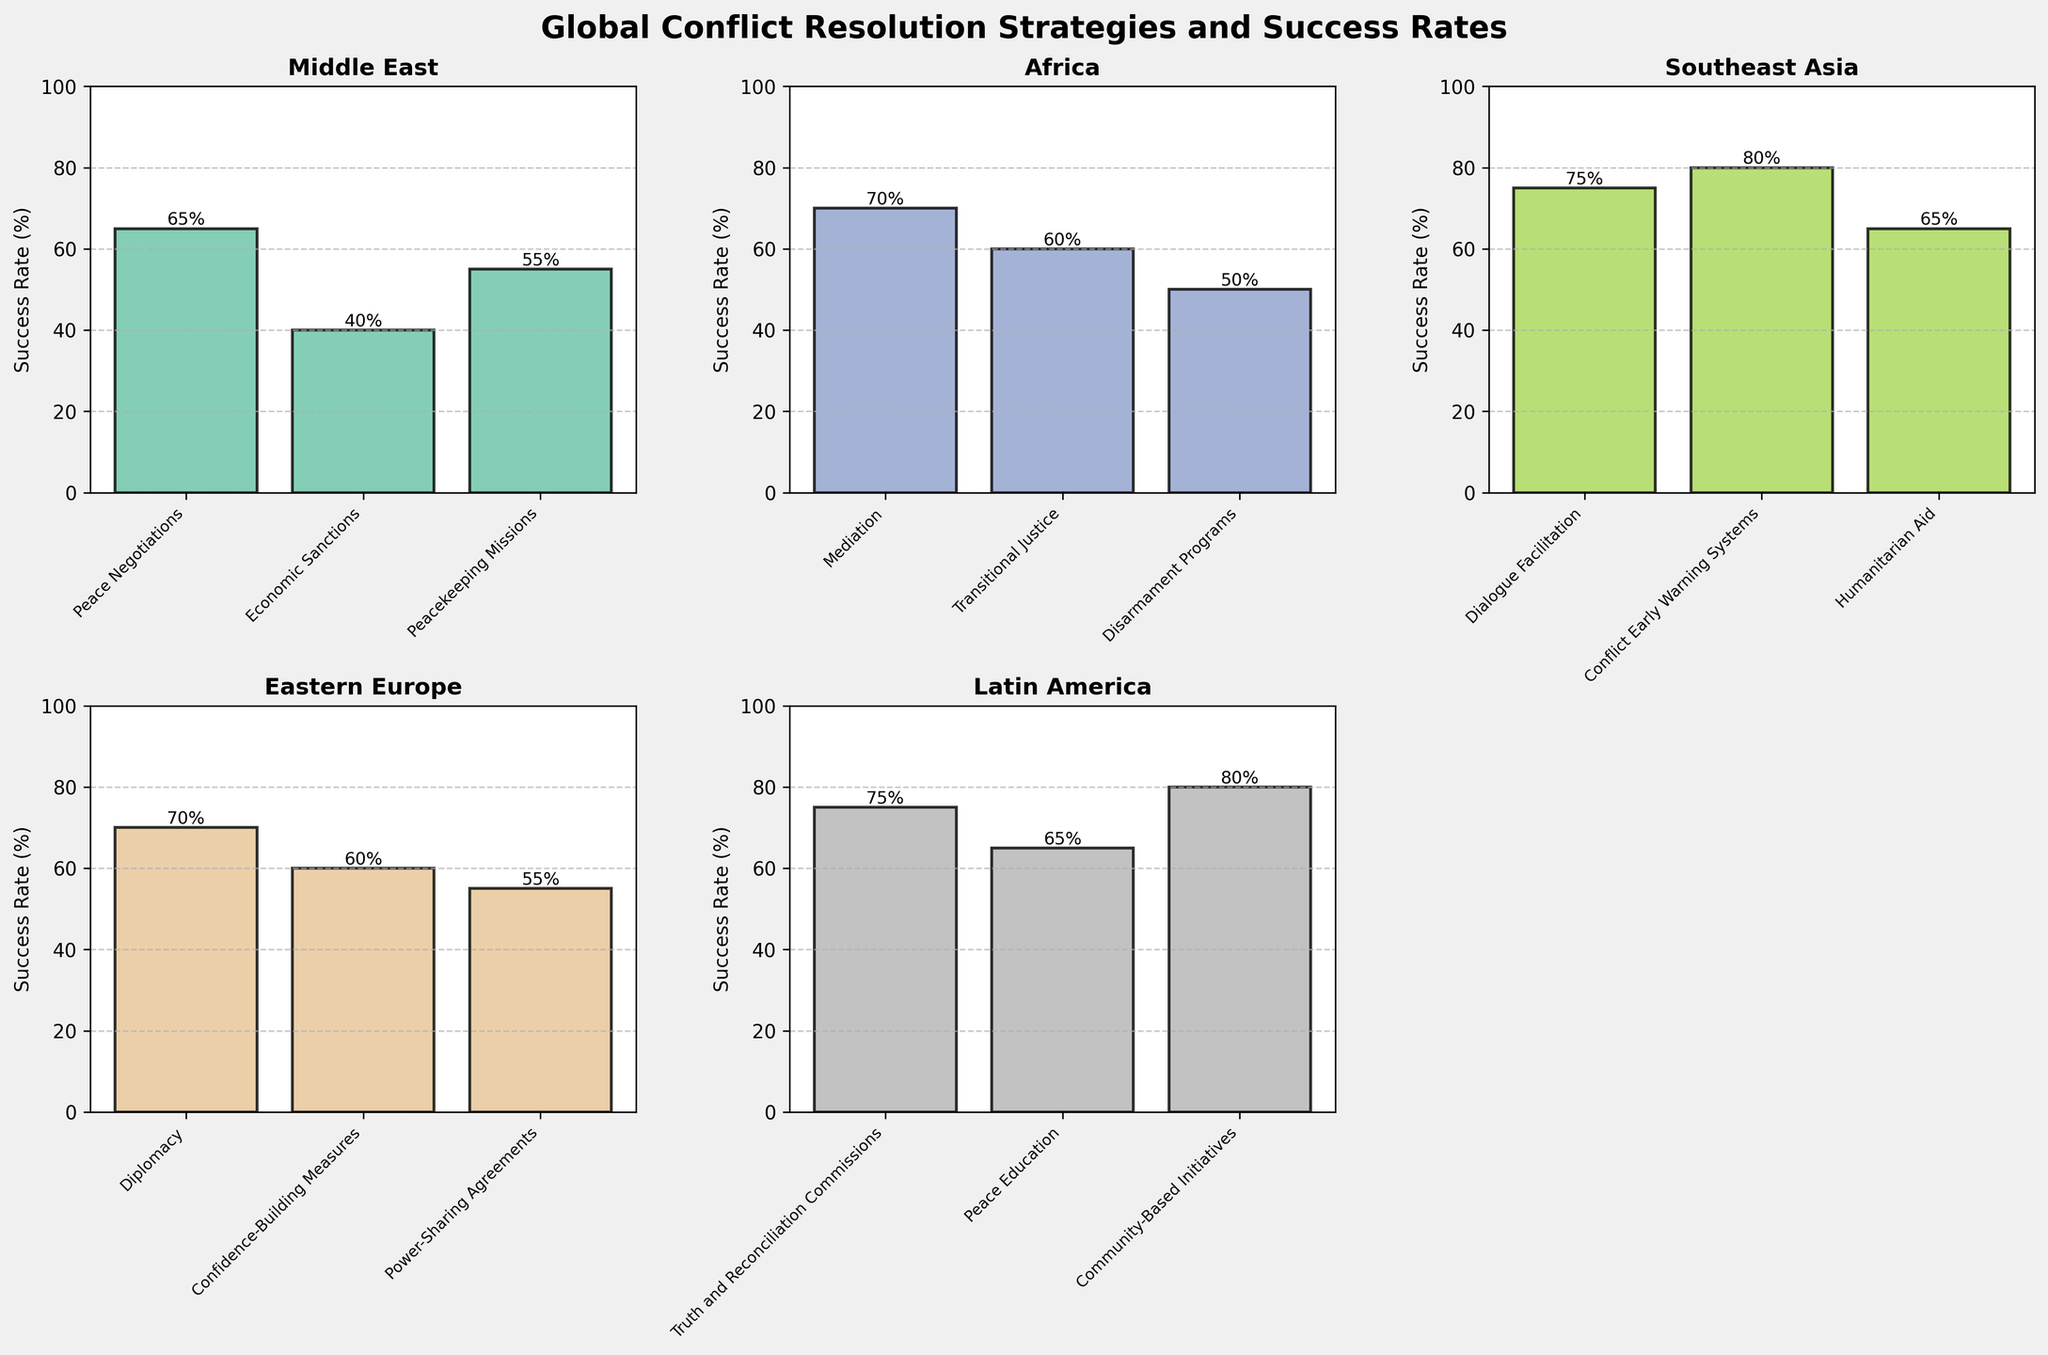What is the title of the figure? The title of the figure is displayed at the top center of the entire plot. It reads "Global Conflict Resolution Strategies and Success Rates" in bold font.
Answer: Global Conflict Resolution Strategies and Success Rates Which region has the highest average success rate across all strategies? To find the average success rate for each region, sum the success rates of all strategies within that region and divide by the number of strategies.
Answer: Southeast Asia How does the success rate of Disarmament Programs in Africa compare to Peacekeeping Missions in the Middle East? Disarmament Programs in Africa have a success rate of 50%, while Peacekeeping Missions in the Middle East have a success rate of 55%. By comparing these values, Peacekeeping Missions in the Middle East have a higher success rate.
Answer: Peacekeeping Missions in the Middle East have a higher success rate What is the range of success rates for strategies in Eastern Europe? The success rates in Eastern Europe are: Diplomacy (70%), Confidence-Building Measures (60%), and Power-Sharing Agreements (55%). The range is calculated as the difference between the maximum and minimum values: 70% - 55% = 15%.
Answer: 15% Which strategy has the highest success rate in Southeast Asia? By looking at the bars for Southeast Asia, Conflict Early Warning Systems has the highest success rate at 80%.
Answer: Conflict Early Warning Systems How many regions have at least one strategy with a success rate of 70% or higher? By examining each subplot, the regions that meet this criterion are Africa, Southeast Asia, Eastern Europe, and Latin America. Therefore, there are 4 regions.
Answer: 4 What is the total success rate of all strategies in the Latin America region? The strategies in Latin America have success rates of 75%, 65%, and 80%. Summing these values gives 75% + 65% + 80% = 220%.
Answer: 220% Which region has the most even distribution of success rates across all their strategies? To determine this, we visually identify the subplot where the bars are closest in height. The Middle East and Eastern Europe have similar heights, but Eastern Europe appears slightly more even.
Answer: Eastern Europe Which strategy has the lowest success rate in the entire plot? By scanning all subplots, the lowest success rate observed is Economic Sanctions in the Middle East with 40%.
Answer: Economic Sanctions in the Middle East What is the average success rate of Peace Negotiations in the Middle East and Mediation in Africa? The success rate for Peace Negotiations in the Middle East is 65%. The success rate for Mediation in Africa is 70%. The average is (65 + 70) / 2 = 67.5%.
Answer: 67.5% 